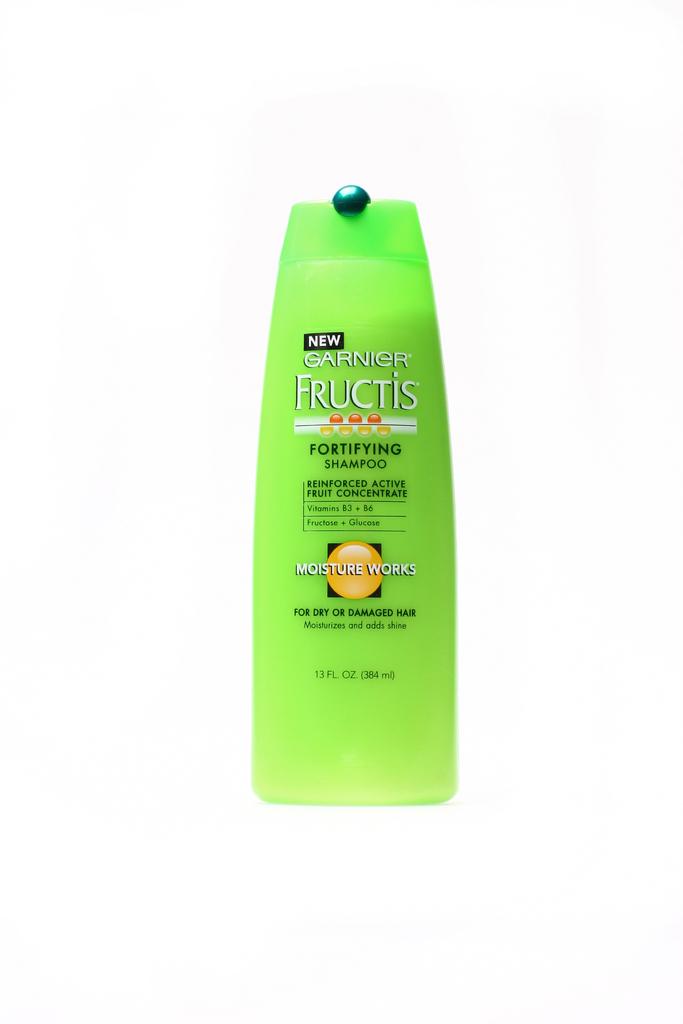What kind of hair is this shampoo for?
Your response must be concise. Dry or damaged. What is the size of the bottle?
Offer a terse response. 13 fl oz. 